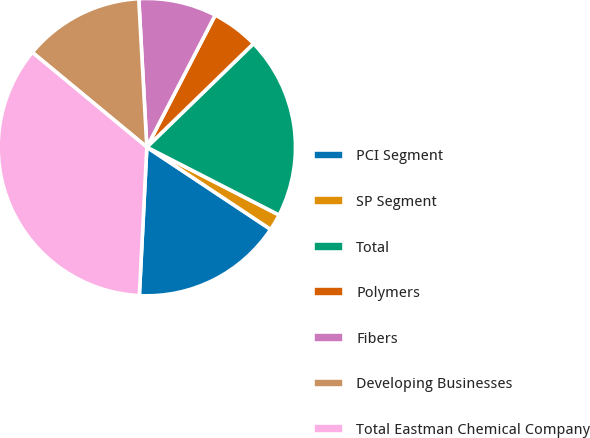Convert chart. <chart><loc_0><loc_0><loc_500><loc_500><pie_chart><fcel>PCI Segment<fcel>SP Segment<fcel>Total<fcel>Polymers<fcel>Fibers<fcel>Developing Businesses<fcel>Total Eastman Chemical Company<nl><fcel>16.47%<fcel>1.79%<fcel>19.81%<fcel>5.13%<fcel>8.47%<fcel>13.13%<fcel>35.2%<nl></chart> 